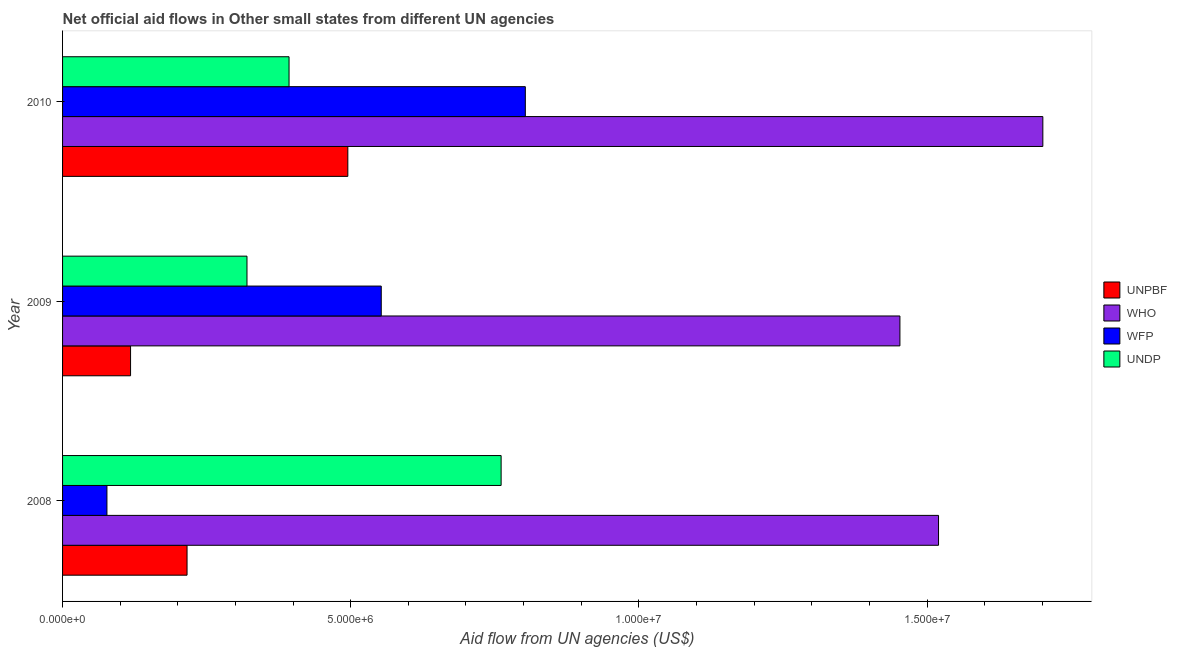How many bars are there on the 2nd tick from the bottom?
Offer a terse response. 4. What is the amount of aid given by wfp in 2009?
Make the answer very short. 5.53e+06. Across all years, what is the maximum amount of aid given by unpbf?
Provide a short and direct response. 4.95e+06. Across all years, what is the minimum amount of aid given by who?
Provide a succinct answer. 1.45e+07. In which year was the amount of aid given by who minimum?
Provide a short and direct response. 2009. What is the total amount of aid given by undp in the graph?
Your answer should be compact. 1.47e+07. What is the difference between the amount of aid given by wfp in 2009 and that in 2010?
Offer a very short reply. -2.50e+06. What is the difference between the amount of aid given by undp in 2009 and the amount of aid given by unpbf in 2010?
Your response must be concise. -1.75e+06. What is the average amount of aid given by wfp per year?
Provide a succinct answer. 4.78e+06. In the year 2008, what is the difference between the amount of aid given by undp and amount of aid given by who?
Provide a short and direct response. -7.59e+06. What is the ratio of the amount of aid given by unpbf in 2009 to that in 2010?
Make the answer very short. 0.24. Is the amount of aid given by unpbf in 2008 less than that in 2010?
Offer a very short reply. Yes. What is the difference between the highest and the second highest amount of aid given by who?
Provide a short and direct response. 1.81e+06. What is the difference between the highest and the lowest amount of aid given by unpbf?
Offer a terse response. 3.77e+06. Is the sum of the amount of aid given by wfp in 2008 and 2010 greater than the maximum amount of aid given by unpbf across all years?
Keep it short and to the point. Yes. Is it the case that in every year, the sum of the amount of aid given by undp and amount of aid given by unpbf is greater than the sum of amount of aid given by wfp and amount of aid given by who?
Keep it short and to the point. No. What does the 1st bar from the top in 2008 represents?
Provide a short and direct response. UNDP. What does the 1st bar from the bottom in 2009 represents?
Ensure brevity in your answer.  UNPBF. Is it the case that in every year, the sum of the amount of aid given by unpbf and amount of aid given by who is greater than the amount of aid given by wfp?
Ensure brevity in your answer.  Yes. How many years are there in the graph?
Your answer should be compact. 3. Are the values on the major ticks of X-axis written in scientific E-notation?
Make the answer very short. Yes. Does the graph contain any zero values?
Your answer should be very brief. No. Where does the legend appear in the graph?
Keep it short and to the point. Center right. How are the legend labels stacked?
Ensure brevity in your answer.  Vertical. What is the title of the graph?
Your answer should be compact. Net official aid flows in Other small states from different UN agencies. Does "Third 20% of population" appear as one of the legend labels in the graph?
Give a very brief answer. No. What is the label or title of the X-axis?
Keep it short and to the point. Aid flow from UN agencies (US$). What is the Aid flow from UN agencies (US$) of UNPBF in 2008?
Your response must be concise. 2.16e+06. What is the Aid flow from UN agencies (US$) of WHO in 2008?
Offer a terse response. 1.52e+07. What is the Aid flow from UN agencies (US$) in WFP in 2008?
Offer a very short reply. 7.70e+05. What is the Aid flow from UN agencies (US$) of UNDP in 2008?
Offer a very short reply. 7.61e+06. What is the Aid flow from UN agencies (US$) in UNPBF in 2009?
Provide a succinct answer. 1.18e+06. What is the Aid flow from UN agencies (US$) in WHO in 2009?
Give a very brief answer. 1.45e+07. What is the Aid flow from UN agencies (US$) in WFP in 2009?
Your answer should be very brief. 5.53e+06. What is the Aid flow from UN agencies (US$) of UNDP in 2009?
Offer a terse response. 3.20e+06. What is the Aid flow from UN agencies (US$) of UNPBF in 2010?
Provide a short and direct response. 4.95e+06. What is the Aid flow from UN agencies (US$) in WHO in 2010?
Your answer should be very brief. 1.70e+07. What is the Aid flow from UN agencies (US$) in WFP in 2010?
Provide a short and direct response. 8.03e+06. What is the Aid flow from UN agencies (US$) in UNDP in 2010?
Your response must be concise. 3.93e+06. Across all years, what is the maximum Aid flow from UN agencies (US$) of UNPBF?
Your response must be concise. 4.95e+06. Across all years, what is the maximum Aid flow from UN agencies (US$) of WHO?
Ensure brevity in your answer.  1.70e+07. Across all years, what is the maximum Aid flow from UN agencies (US$) in WFP?
Ensure brevity in your answer.  8.03e+06. Across all years, what is the maximum Aid flow from UN agencies (US$) of UNDP?
Keep it short and to the point. 7.61e+06. Across all years, what is the minimum Aid flow from UN agencies (US$) of UNPBF?
Provide a succinct answer. 1.18e+06. Across all years, what is the minimum Aid flow from UN agencies (US$) of WHO?
Provide a short and direct response. 1.45e+07. Across all years, what is the minimum Aid flow from UN agencies (US$) in WFP?
Provide a short and direct response. 7.70e+05. Across all years, what is the minimum Aid flow from UN agencies (US$) in UNDP?
Your answer should be compact. 3.20e+06. What is the total Aid flow from UN agencies (US$) in UNPBF in the graph?
Your answer should be compact. 8.29e+06. What is the total Aid flow from UN agencies (US$) of WHO in the graph?
Provide a short and direct response. 4.67e+07. What is the total Aid flow from UN agencies (US$) in WFP in the graph?
Ensure brevity in your answer.  1.43e+07. What is the total Aid flow from UN agencies (US$) of UNDP in the graph?
Provide a succinct answer. 1.47e+07. What is the difference between the Aid flow from UN agencies (US$) of UNPBF in 2008 and that in 2009?
Provide a succinct answer. 9.80e+05. What is the difference between the Aid flow from UN agencies (US$) of WHO in 2008 and that in 2009?
Ensure brevity in your answer.  6.70e+05. What is the difference between the Aid flow from UN agencies (US$) in WFP in 2008 and that in 2009?
Offer a very short reply. -4.76e+06. What is the difference between the Aid flow from UN agencies (US$) in UNDP in 2008 and that in 2009?
Make the answer very short. 4.41e+06. What is the difference between the Aid flow from UN agencies (US$) of UNPBF in 2008 and that in 2010?
Make the answer very short. -2.79e+06. What is the difference between the Aid flow from UN agencies (US$) of WHO in 2008 and that in 2010?
Your answer should be very brief. -1.81e+06. What is the difference between the Aid flow from UN agencies (US$) in WFP in 2008 and that in 2010?
Provide a succinct answer. -7.26e+06. What is the difference between the Aid flow from UN agencies (US$) of UNDP in 2008 and that in 2010?
Give a very brief answer. 3.68e+06. What is the difference between the Aid flow from UN agencies (US$) of UNPBF in 2009 and that in 2010?
Provide a short and direct response. -3.77e+06. What is the difference between the Aid flow from UN agencies (US$) in WHO in 2009 and that in 2010?
Provide a succinct answer. -2.48e+06. What is the difference between the Aid flow from UN agencies (US$) in WFP in 2009 and that in 2010?
Make the answer very short. -2.50e+06. What is the difference between the Aid flow from UN agencies (US$) of UNDP in 2009 and that in 2010?
Your answer should be very brief. -7.30e+05. What is the difference between the Aid flow from UN agencies (US$) in UNPBF in 2008 and the Aid flow from UN agencies (US$) in WHO in 2009?
Give a very brief answer. -1.24e+07. What is the difference between the Aid flow from UN agencies (US$) of UNPBF in 2008 and the Aid flow from UN agencies (US$) of WFP in 2009?
Give a very brief answer. -3.37e+06. What is the difference between the Aid flow from UN agencies (US$) of UNPBF in 2008 and the Aid flow from UN agencies (US$) of UNDP in 2009?
Ensure brevity in your answer.  -1.04e+06. What is the difference between the Aid flow from UN agencies (US$) of WHO in 2008 and the Aid flow from UN agencies (US$) of WFP in 2009?
Keep it short and to the point. 9.67e+06. What is the difference between the Aid flow from UN agencies (US$) in WFP in 2008 and the Aid flow from UN agencies (US$) in UNDP in 2009?
Give a very brief answer. -2.43e+06. What is the difference between the Aid flow from UN agencies (US$) of UNPBF in 2008 and the Aid flow from UN agencies (US$) of WHO in 2010?
Make the answer very short. -1.48e+07. What is the difference between the Aid flow from UN agencies (US$) in UNPBF in 2008 and the Aid flow from UN agencies (US$) in WFP in 2010?
Ensure brevity in your answer.  -5.87e+06. What is the difference between the Aid flow from UN agencies (US$) of UNPBF in 2008 and the Aid flow from UN agencies (US$) of UNDP in 2010?
Make the answer very short. -1.77e+06. What is the difference between the Aid flow from UN agencies (US$) of WHO in 2008 and the Aid flow from UN agencies (US$) of WFP in 2010?
Offer a very short reply. 7.17e+06. What is the difference between the Aid flow from UN agencies (US$) of WHO in 2008 and the Aid flow from UN agencies (US$) of UNDP in 2010?
Your answer should be very brief. 1.13e+07. What is the difference between the Aid flow from UN agencies (US$) in WFP in 2008 and the Aid flow from UN agencies (US$) in UNDP in 2010?
Provide a short and direct response. -3.16e+06. What is the difference between the Aid flow from UN agencies (US$) in UNPBF in 2009 and the Aid flow from UN agencies (US$) in WHO in 2010?
Ensure brevity in your answer.  -1.58e+07. What is the difference between the Aid flow from UN agencies (US$) in UNPBF in 2009 and the Aid flow from UN agencies (US$) in WFP in 2010?
Give a very brief answer. -6.85e+06. What is the difference between the Aid flow from UN agencies (US$) in UNPBF in 2009 and the Aid flow from UN agencies (US$) in UNDP in 2010?
Make the answer very short. -2.75e+06. What is the difference between the Aid flow from UN agencies (US$) in WHO in 2009 and the Aid flow from UN agencies (US$) in WFP in 2010?
Offer a terse response. 6.50e+06. What is the difference between the Aid flow from UN agencies (US$) of WHO in 2009 and the Aid flow from UN agencies (US$) of UNDP in 2010?
Provide a short and direct response. 1.06e+07. What is the difference between the Aid flow from UN agencies (US$) in WFP in 2009 and the Aid flow from UN agencies (US$) in UNDP in 2010?
Give a very brief answer. 1.60e+06. What is the average Aid flow from UN agencies (US$) in UNPBF per year?
Your answer should be very brief. 2.76e+06. What is the average Aid flow from UN agencies (US$) of WHO per year?
Give a very brief answer. 1.56e+07. What is the average Aid flow from UN agencies (US$) of WFP per year?
Your answer should be very brief. 4.78e+06. What is the average Aid flow from UN agencies (US$) of UNDP per year?
Provide a short and direct response. 4.91e+06. In the year 2008, what is the difference between the Aid flow from UN agencies (US$) of UNPBF and Aid flow from UN agencies (US$) of WHO?
Provide a short and direct response. -1.30e+07. In the year 2008, what is the difference between the Aid flow from UN agencies (US$) of UNPBF and Aid flow from UN agencies (US$) of WFP?
Offer a terse response. 1.39e+06. In the year 2008, what is the difference between the Aid flow from UN agencies (US$) in UNPBF and Aid flow from UN agencies (US$) in UNDP?
Offer a very short reply. -5.45e+06. In the year 2008, what is the difference between the Aid flow from UN agencies (US$) of WHO and Aid flow from UN agencies (US$) of WFP?
Make the answer very short. 1.44e+07. In the year 2008, what is the difference between the Aid flow from UN agencies (US$) in WHO and Aid flow from UN agencies (US$) in UNDP?
Make the answer very short. 7.59e+06. In the year 2008, what is the difference between the Aid flow from UN agencies (US$) in WFP and Aid flow from UN agencies (US$) in UNDP?
Your answer should be compact. -6.84e+06. In the year 2009, what is the difference between the Aid flow from UN agencies (US$) in UNPBF and Aid flow from UN agencies (US$) in WHO?
Ensure brevity in your answer.  -1.34e+07. In the year 2009, what is the difference between the Aid flow from UN agencies (US$) of UNPBF and Aid flow from UN agencies (US$) of WFP?
Offer a very short reply. -4.35e+06. In the year 2009, what is the difference between the Aid flow from UN agencies (US$) of UNPBF and Aid flow from UN agencies (US$) of UNDP?
Your answer should be very brief. -2.02e+06. In the year 2009, what is the difference between the Aid flow from UN agencies (US$) in WHO and Aid flow from UN agencies (US$) in WFP?
Your response must be concise. 9.00e+06. In the year 2009, what is the difference between the Aid flow from UN agencies (US$) of WHO and Aid flow from UN agencies (US$) of UNDP?
Provide a succinct answer. 1.13e+07. In the year 2009, what is the difference between the Aid flow from UN agencies (US$) in WFP and Aid flow from UN agencies (US$) in UNDP?
Give a very brief answer. 2.33e+06. In the year 2010, what is the difference between the Aid flow from UN agencies (US$) of UNPBF and Aid flow from UN agencies (US$) of WHO?
Keep it short and to the point. -1.21e+07. In the year 2010, what is the difference between the Aid flow from UN agencies (US$) of UNPBF and Aid flow from UN agencies (US$) of WFP?
Provide a succinct answer. -3.08e+06. In the year 2010, what is the difference between the Aid flow from UN agencies (US$) of UNPBF and Aid flow from UN agencies (US$) of UNDP?
Give a very brief answer. 1.02e+06. In the year 2010, what is the difference between the Aid flow from UN agencies (US$) of WHO and Aid flow from UN agencies (US$) of WFP?
Ensure brevity in your answer.  8.98e+06. In the year 2010, what is the difference between the Aid flow from UN agencies (US$) in WHO and Aid flow from UN agencies (US$) in UNDP?
Give a very brief answer. 1.31e+07. In the year 2010, what is the difference between the Aid flow from UN agencies (US$) in WFP and Aid flow from UN agencies (US$) in UNDP?
Provide a short and direct response. 4.10e+06. What is the ratio of the Aid flow from UN agencies (US$) of UNPBF in 2008 to that in 2009?
Provide a succinct answer. 1.83. What is the ratio of the Aid flow from UN agencies (US$) in WHO in 2008 to that in 2009?
Your response must be concise. 1.05. What is the ratio of the Aid flow from UN agencies (US$) in WFP in 2008 to that in 2009?
Your response must be concise. 0.14. What is the ratio of the Aid flow from UN agencies (US$) of UNDP in 2008 to that in 2009?
Provide a succinct answer. 2.38. What is the ratio of the Aid flow from UN agencies (US$) in UNPBF in 2008 to that in 2010?
Provide a succinct answer. 0.44. What is the ratio of the Aid flow from UN agencies (US$) in WHO in 2008 to that in 2010?
Give a very brief answer. 0.89. What is the ratio of the Aid flow from UN agencies (US$) of WFP in 2008 to that in 2010?
Provide a succinct answer. 0.1. What is the ratio of the Aid flow from UN agencies (US$) in UNDP in 2008 to that in 2010?
Offer a terse response. 1.94. What is the ratio of the Aid flow from UN agencies (US$) of UNPBF in 2009 to that in 2010?
Provide a succinct answer. 0.24. What is the ratio of the Aid flow from UN agencies (US$) of WHO in 2009 to that in 2010?
Your response must be concise. 0.85. What is the ratio of the Aid flow from UN agencies (US$) of WFP in 2009 to that in 2010?
Your answer should be very brief. 0.69. What is the ratio of the Aid flow from UN agencies (US$) of UNDP in 2009 to that in 2010?
Provide a short and direct response. 0.81. What is the difference between the highest and the second highest Aid flow from UN agencies (US$) of UNPBF?
Your answer should be compact. 2.79e+06. What is the difference between the highest and the second highest Aid flow from UN agencies (US$) of WHO?
Ensure brevity in your answer.  1.81e+06. What is the difference between the highest and the second highest Aid flow from UN agencies (US$) in WFP?
Offer a terse response. 2.50e+06. What is the difference between the highest and the second highest Aid flow from UN agencies (US$) of UNDP?
Offer a terse response. 3.68e+06. What is the difference between the highest and the lowest Aid flow from UN agencies (US$) in UNPBF?
Your answer should be very brief. 3.77e+06. What is the difference between the highest and the lowest Aid flow from UN agencies (US$) in WHO?
Make the answer very short. 2.48e+06. What is the difference between the highest and the lowest Aid flow from UN agencies (US$) in WFP?
Provide a succinct answer. 7.26e+06. What is the difference between the highest and the lowest Aid flow from UN agencies (US$) of UNDP?
Your response must be concise. 4.41e+06. 